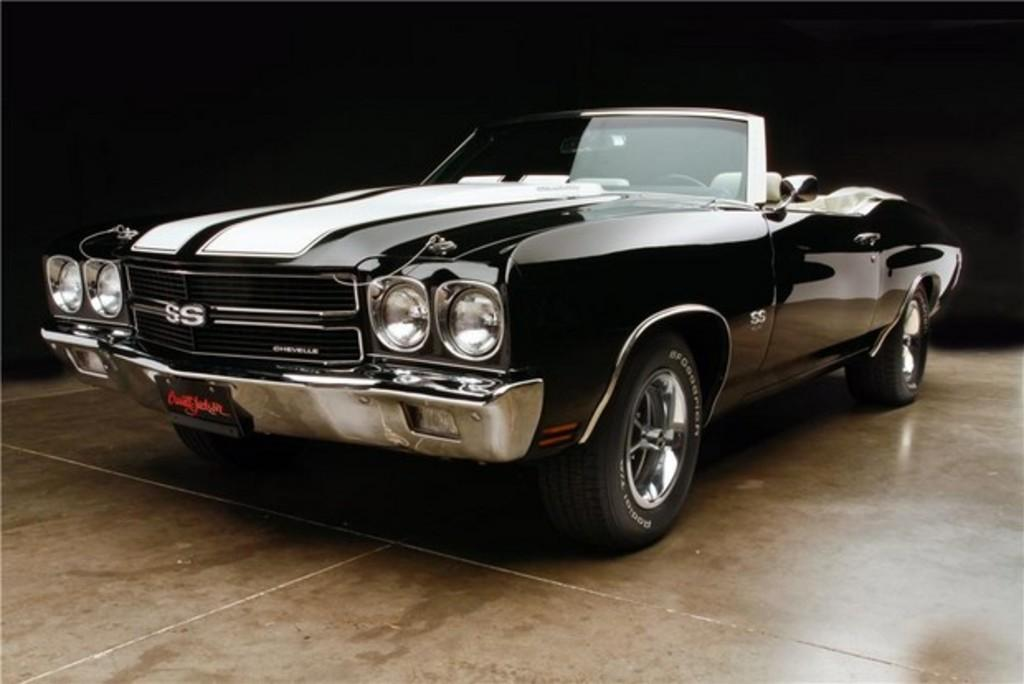What is the main subject of the image? There is a car in the image. Can you describe any specific details about the car? There is text written on the car's plates. What is visible beneath the car in the image? The floor is visible in the image. What type of toothpaste is being used in the battle depicted in the image? There is no battle or toothpaste present in the image; it features a car with text on its plates and a visible floor. 